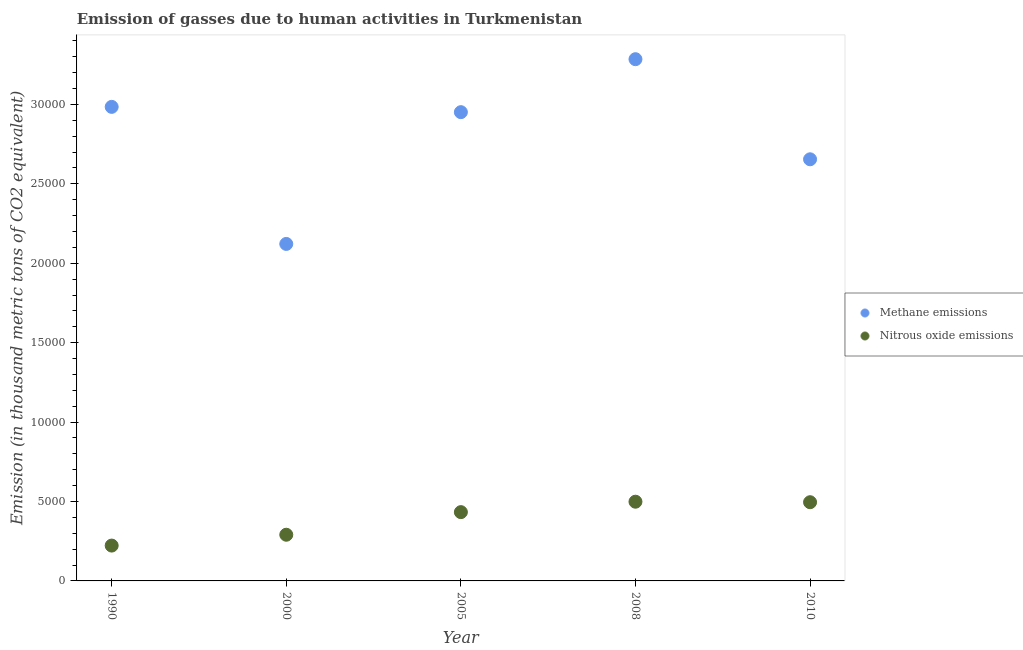What is the amount of nitrous oxide emissions in 2000?
Keep it short and to the point. 2907.9. Across all years, what is the maximum amount of methane emissions?
Offer a very short reply. 3.28e+04. Across all years, what is the minimum amount of nitrous oxide emissions?
Provide a succinct answer. 2225.1. In which year was the amount of methane emissions minimum?
Offer a terse response. 2000. What is the total amount of nitrous oxide emissions in the graph?
Offer a terse response. 1.94e+04. What is the difference between the amount of nitrous oxide emissions in 2008 and that in 2010?
Offer a very short reply. 31.9. What is the difference between the amount of methane emissions in 2008 and the amount of nitrous oxide emissions in 2005?
Your answer should be compact. 2.85e+04. What is the average amount of methane emissions per year?
Ensure brevity in your answer.  2.80e+04. In the year 2000, what is the difference between the amount of nitrous oxide emissions and amount of methane emissions?
Ensure brevity in your answer.  -1.83e+04. What is the ratio of the amount of nitrous oxide emissions in 1990 to that in 2000?
Make the answer very short. 0.77. What is the difference between the highest and the second highest amount of methane emissions?
Give a very brief answer. 3001.5. What is the difference between the highest and the lowest amount of methane emissions?
Make the answer very short. 1.16e+04. Is the amount of nitrous oxide emissions strictly greater than the amount of methane emissions over the years?
Offer a very short reply. No. Is the amount of methane emissions strictly less than the amount of nitrous oxide emissions over the years?
Your response must be concise. No. Does the graph contain grids?
Provide a succinct answer. No. Where does the legend appear in the graph?
Ensure brevity in your answer.  Center right. How are the legend labels stacked?
Provide a succinct answer. Vertical. What is the title of the graph?
Your response must be concise. Emission of gasses due to human activities in Turkmenistan. What is the label or title of the Y-axis?
Provide a succinct answer. Emission (in thousand metric tons of CO2 equivalent). What is the Emission (in thousand metric tons of CO2 equivalent) of Methane emissions in 1990?
Provide a succinct answer. 2.98e+04. What is the Emission (in thousand metric tons of CO2 equivalent) of Nitrous oxide emissions in 1990?
Give a very brief answer. 2225.1. What is the Emission (in thousand metric tons of CO2 equivalent) of Methane emissions in 2000?
Your answer should be compact. 2.12e+04. What is the Emission (in thousand metric tons of CO2 equivalent) in Nitrous oxide emissions in 2000?
Your answer should be compact. 2907.9. What is the Emission (in thousand metric tons of CO2 equivalent) of Methane emissions in 2005?
Offer a very short reply. 2.95e+04. What is the Emission (in thousand metric tons of CO2 equivalent) in Nitrous oxide emissions in 2005?
Provide a succinct answer. 4330.6. What is the Emission (in thousand metric tons of CO2 equivalent) in Methane emissions in 2008?
Your response must be concise. 3.28e+04. What is the Emission (in thousand metric tons of CO2 equivalent) of Nitrous oxide emissions in 2008?
Your response must be concise. 4987.1. What is the Emission (in thousand metric tons of CO2 equivalent) in Methane emissions in 2010?
Your answer should be very brief. 2.65e+04. What is the Emission (in thousand metric tons of CO2 equivalent) of Nitrous oxide emissions in 2010?
Give a very brief answer. 4955.2. Across all years, what is the maximum Emission (in thousand metric tons of CO2 equivalent) of Methane emissions?
Your answer should be very brief. 3.28e+04. Across all years, what is the maximum Emission (in thousand metric tons of CO2 equivalent) of Nitrous oxide emissions?
Provide a short and direct response. 4987.1. Across all years, what is the minimum Emission (in thousand metric tons of CO2 equivalent) in Methane emissions?
Offer a terse response. 2.12e+04. Across all years, what is the minimum Emission (in thousand metric tons of CO2 equivalent) of Nitrous oxide emissions?
Provide a short and direct response. 2225.1. What is the total Emission (in thousand metric tons of CO2 equivalent) of Methane emissions in the graph?
Offer a very short reply. 1.40e+05. What is the total Emission (in thousand metric tons of CO2 equivalent) of Nitrous oxide emissions in the graph?
Offer a very short reply. 1.94e+04. What is the difference between the Emission (in thousand metric tons of CO2 equivalent) of Methane emissions in 1990 and that in 2000?
Provide a succinct answer. 8629.4. What is the difference between the Emission (in thousand metric tons of CO2 equivalent) of Nitrous oxide emissions in 1990 and that in 2000?
Make the answer very short. -682.8. What is the difference between the Emission (in thousand metric tons of CO2 equivalent) in Methane emissions in 1990 and that in 2005?
Make the answer very short. 333.3. What is the difference between the Emission (in thousand metric tons of CO2 equivalent) in Nitrous oxide emissions in 1990 and that in 2005?
Your answer should be very brief. -2105.5. What is the difference between the Emission (in thousand metric tons of CO2 equivalent) in Methane emissions in 1990 and that in 2008?
Ensure brevity in your answer.  -3001.5. What is the difference between the Emission (in thousand metric tons of CO2 equivalent) in Nitrous oxide emissions in 1990 and that in 2008?
Your answer should be compact. -2762. What is the difference between the Emission (in thousand metric tons of CO2 equivalent) of Methane emissions in 1990 and that in 2010?
Provide a succinct answer. 3300.5. What is the difference between the Emission (in thousand metric tons of CO2 equivalent) in Nitrous oxide emissions in 1990 and that in 2010?
Ensure brevity in your answer.  -2730.1. What is the difference between the Emission (in thousand metric tons of CO2 equivalent) in Methane emissions in 2000 and that in 2005?
Make the answer very short. -8296.1. What is the difference between the Emission (in thousand metric tons of CO2 equivalent) of Nitrous oxide emissions in 2000 and that in 2005?
Your answer should be compact. -1422.7. What is the difference between the Emission (in thousand metric tons of CO2 equivalent) in Methane emissions in 2000 and that in 2008?
Your answer should be very brief. -1.16e+04. What is the difference between the Emission (in thousand metric tons of CO2 equivalent) in Nitrous oxide emissions in 2000 and that in 2008?
Give a very brief answer. -2079.2. What is the difference between the Emission (in thousand metric tons of CO2 equivalent) in Methane emissions in 2000 and that in 2010?
Your answer should be very brief. -5328.9. What is the difference between the Emission (in thousand metric tons of CO2 equivalent) in Nitrous oxide emissions in 2000 and that in 2010?
Offer a terse response. -2047.3. What is the difference between the Emission (in thousand metric tons of CO2 equivalent) in Methane emissions in 2005 and that in 2008?
Provide a succinct answer. -3334.8. What is the difference between the Emission (in thousand metric tons of CO2 equivalent) in Nitrous oxide emissions in 2005 and that in 2008?
Provide a short and direct response. -656.5. What is the difference between the Emission (in thousand metric tons of CO2 equivalent) of Methane emissions in 2005 and that in 2010?
Keep it short and to the point. 2967.2. What is the difference between the Emission (in thousand metric tons of CO2 equivalent) of Nitrous oxide emissions in 2005 and that in 2010?
Give a very brief answer. -624.6. What is the difference between the Emission (in thousand metric tons of CO2 equivalent) of Methane emissions in 2008 and that in 2010?
Your answer should be compact. 6302. What is the difference between the Emission (in thousand metric tons of CO2 equivalent) in Nitrous oxide emissions in 2008 and that in 2010?
Your response must be concise. 31.9. What is the difference between the Emission (in thousand metric tons of CO2 equivalent) in Methane emissions in 1990 and the Emission (in thousand metric tons of CO2 equivalent) in Nitrous oxide emissions in 2000?
Your answer should be compact. 2.69e+04. What is the difference between the Emission (in thousand metric tons of CO2 equivalent) of Methane emissions in 1990 and the Emission (in thousand metric tons of CO2 equivalent) of Nitrous oxide emissions in 2005?
Give a very brief answer. 2.55e+04. What is the difference between the Emission (in thousand metric tons of CO2 equivalent) of Methane emissions in 1990 and the Emission (in thousand metric tons of CO2 equivalent) of Nitrous oxide emissions in 2008?
Your answer should be very brief. 2.49e+04. What is the difference between the Emission (in thousand metric tons of CO2 equivalent) of Methane emissions in 1990 and the Emission (in thousand metric tons of CO2 equivalent) of Nitrous oxide emissions in 2010?
Provide a succinct answer. 2.49e+04. What is the difference between the Emission (in thousand metric tons of CO2 equivalent) of Methane emissions in 2000 and the Emission (in thousand metric tons of CO2 equivalent) of Nitrous oxide emissions in 2005?
Give a very brief answer. 1.69e+04. What is the difference between the Emission (in thousand metric tons of CO2 equivalent) of Methane emissions in 2000 and the Emission (in thousand metric tons of CO2 equivalent) of Nitrous oxide emissions in 2008?
Ensure brevity in your answer.  1.62e+04. What is the difference between the Emission (in thousand metric tons of CO2 equivalent) of Methane emissions in 2000 and the Emission (in thousand metric tons of CO2 equivalent) of Nitrous oxide emissions in 2010?
Your response must be concise. 1.63e+04. What is the difference between the Emission (in thousand metric tons of CO2 equivalent) of Methane emissions in 2005 and the Emission (in thousand metric tons of CO2 equivalent) of Nitrous oxide emissions in 2008?
Ensure brevity in your answer.  2.45e+04. What is the difference between the Emission (in thousand metric tons of CO2 equivalent) of Methane emissions in 2005 and the Emission (in thousand metric tons of CO2 equivalent) of Nitrous oxide emissions in 2010?
Your answer should be very brief. 2.46e+04. What is the difference between the Emission (in thousand metric tons of CO2 equivalent) of Methane emissions in 2008 and the Emission (in thousand metric tons of CO2 equivalent) of Nitrous oxide emissions in 2010?
Give a very brief answer. 2.79e+04. What is the average Emission (in thousand metric tons of CO2 equivalent) in Methane emissions per year?
Your answer should be very brief. 2.80e+04. What is the average Emission (in thousand metric tons of CO2 equivalent) of Nitrous oxide emissions per year?
Provide a succinct answer. 3881.18. In the year 1990, what is the difference between the Emission (in thousand metric tons of CO2 equivalent) of Methane emissions and Emission (in thousand metric tons of CO2 equivalent) of Nitrous oxide emissions?
Your answer should be very brief. 2.76e+04. In the year 2000, what is the difference between the Emission (in thousand metric tons of CO2 equivalent) of Methane emissions and Emission (in thousand metric tons of CO2 equivalent) of Nitrous oxide emissions?
Give a very brief answer. 1.83e+04. In the year 2005, what is the difference between the Emission (in thousand metric tons of CO2 equivalent) in Methane emissions and Emission (in thousand metric tons of CO2 equivalent) in Nitrous oxide emissions?
Offer a terse response. 2.52e+04. In the year 2008, what is the difference between the Emission (in thousand metric tons of CO2 equivalent) of Methane emissions and Emission (in thousand metric tons of CO2 equivalent) of Nitrous oxide emissions?
Your answer should be very brief. 2.79e+04. In the year 2010, what is the difference between the Emission (in thousand metric tons of CO2 equivalent) of Methane emissions and Emission (in thousand metric tons of CO2 equivalent) of Nitrous oxide emissions?
Make the answer very short. 2.16e+04. What is the ratio of the Emission (in thousand metric tons of CO2 equivalent) in Methane emissions in 1990 to that in 2000?
Your answer should be compact. 1.41. What is the ratio of the Emission (in thousand metric tons of CO2 equivalent) in Nitrous oxide emissions in 1990 to that in 2000?
Your answer should be compact. 0.77. What is the ratio of the Emission (in thousand metric tons of CO2 equivalent) of Methane emissions in 1990 to that in 2005?
Ensure brevity in your answer.  1.01. What is the ratio of the Emission (in thousand metric tons of CO2 equivalent) of Nitrous oxide emissions in 1990 to that in 2005?
Your answer should be very brief. 0.51. What is the ratio of the Emission (in thousand metric tons of CO2 equivalent) of Methane emissions in 1990 to that in 2008?
Offer a very short reply. 0.91. What is the ratio of the Emission (in thousand metric tons of CO2 equivalent) of Nitrous oxide emissions in 1990 to that in 2008?
Offer a very short reply. 0.45. What is the ratio of the Emission (in thousand metric tons of CO2 equivalent) in Methane emissions in 1990 to that in 2010?
Give a very brief answer. 1.12. What is the ratio of the Emission (in thousand metric tons of CO2 equivalent) in Nitrous oxide emissions in 1990 to that in 2010?
Keep it short and to the point. 0.45. What is the ratio of the Emission (in thousand metric tons of CO2 equivalent) in Methane emissions in 2000 to that in 2005?
Provide a succinct answer. 0.72. What is the ratio of the Emission (in thousand metric tons of CO2 equivalent) in Nitrous oxide emissions in 2000 to that in 2005?
Provide a short and direct response. 0.67. What is the ratio of the Emission (in thousand metric tons of CO2 equivalent) of Methane emissions in 2000 to that in 2008?
Your response must be concise. 0.65. What is the ratio of the Emission (in thousand metric tons of CO2 equivalent) of Nitrous oxide emissions in 2000 to that in 2008?
Provide a succinct answer. 0.58. What is the ratio of the Emission (in thousand metric tons of CO2 equivalent) of Methane emissions in 2000 to that in 2010?
Provide a succinct answer. 0.8. What is the ratio of the Emission (in thousand metric tons of CO2 equivalent) of Nitrous oxide emissions in 2000 to that in 2010?
Offer a terse response. 0.59. What is the ratio of the Emission (in thousand metric tons of CO2 equivalent) of Methane emissions in 2005 to that in 2008?
Offer a very short reply. 0.9. What is the ratio of the Emission (in thousand metric tons of CO2 equivalent) of Nitrous oxide emissions in 2005 to that in 2008?
Provide a succinct answer. 0.87. What is the ratio of the Emission (in thousand metric tons of CO2 equivalent) of Methane emissions in 2005 to that in 2010?
Offer a terse response. 1.11. What is the ratio of the Emission (in thousand metric tons of CO2 equivalent) of Nitrous oxide emissions in 2005 to that in 2010?
Offer a terse response. 0.87. What is the ratio of the Emission (in thousand metric tons of CO2 equivalent) in Methane emissions in 2008 to that in 2010?
Offer a terse response. 1.24. What is the ratio of the Emission (in thousand metric tons of CO2 equivalent) in Nitrous oxide emissions in 2008 to that in 2010?
Your answer should be very brief. 1.01. What is the difference between the highest and the second highest Emission (in thousand metric tons of CO2 equivalent) of Methane emissions?
Your answer should be very brief. 3001.5. What is the difference between the highest and the second highest Emission (in thousand metric tons of CO2 equivalent) of Nitrous oxide emissions?
Offer a terse response. 31.9. What is the difference between the highest and the lowest Emission (in thousand metric tons of CO2 equivalent) in Methane emissions?
Give a very brief answer. 1.16e+04. What is the difference between the highest and the lowest Emission (in thousand metric tons of CO2 equivalent) in Nitrous oxide emissions?
Provide a succinct answer. 2762. 